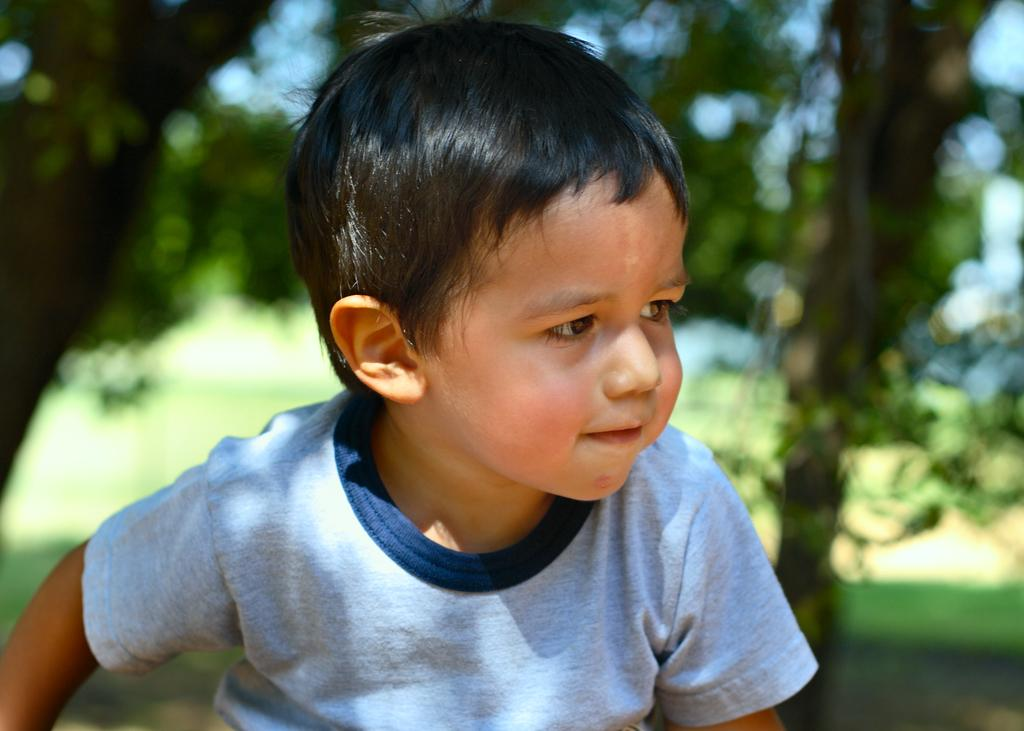What is the main subject in the foreground of the image? There is a boy in the foreground of the image. What can be seen in the background of the image? There are trees and the sky visible in the background of the image. What type of plastic is the boy using to style his hair in the image? There is no plastic or hair styling mentioned in the image; the boy is simply standing in the foreground. 